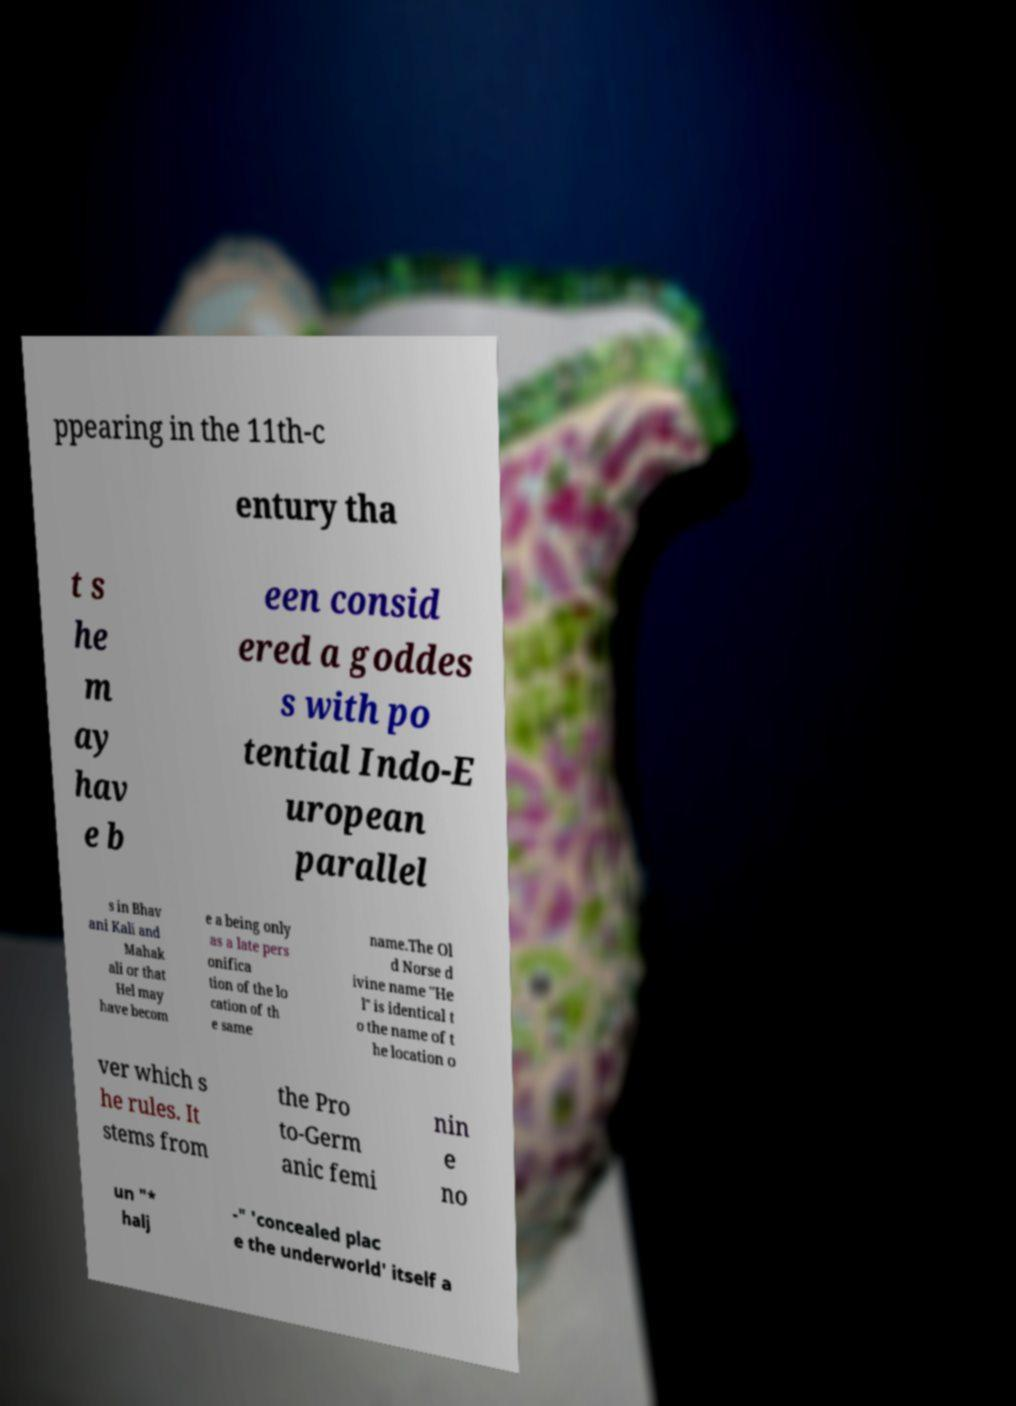What messages or text are displayed in this image? I need them in a readable, typed format. ppearing in the 11th-c entury tha t s he m ay hav e b een consid ered a goddes s with po tential Indo-E uropean parallel s in Bhav ani Kali and Mahak ali or that Hel may have becom e a being only as a late pers onifica tion of the lo cation of th e same name.The Ol d Norse d ivine name "He l" is identical t o the name of t he location o ver which s he rules. It stems from the Pro to-Germ anic femi nin e no un "* halj -" 'concealed plac e the underworld' itself a 